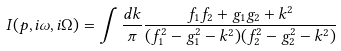<formula> <loc_0><loc_0><loc_500><loc_500>I ( p , i \omega , i \Omega ) = \int \frac { d k } { \pi } \frac { f _ { 1 } f _ { 2 } + g _ { 1 } g _ { 2 } + k ^ { 2 } } { ( f _ { 1 } ^ { 2 } - g _ { 1 } ^ { 2 } - k ^ { 2 } ) ( f _ { 2 } ^ { 2 } - g _ { 2 } ^ { 2 } - k ^ { 2 } ) }</formula> 